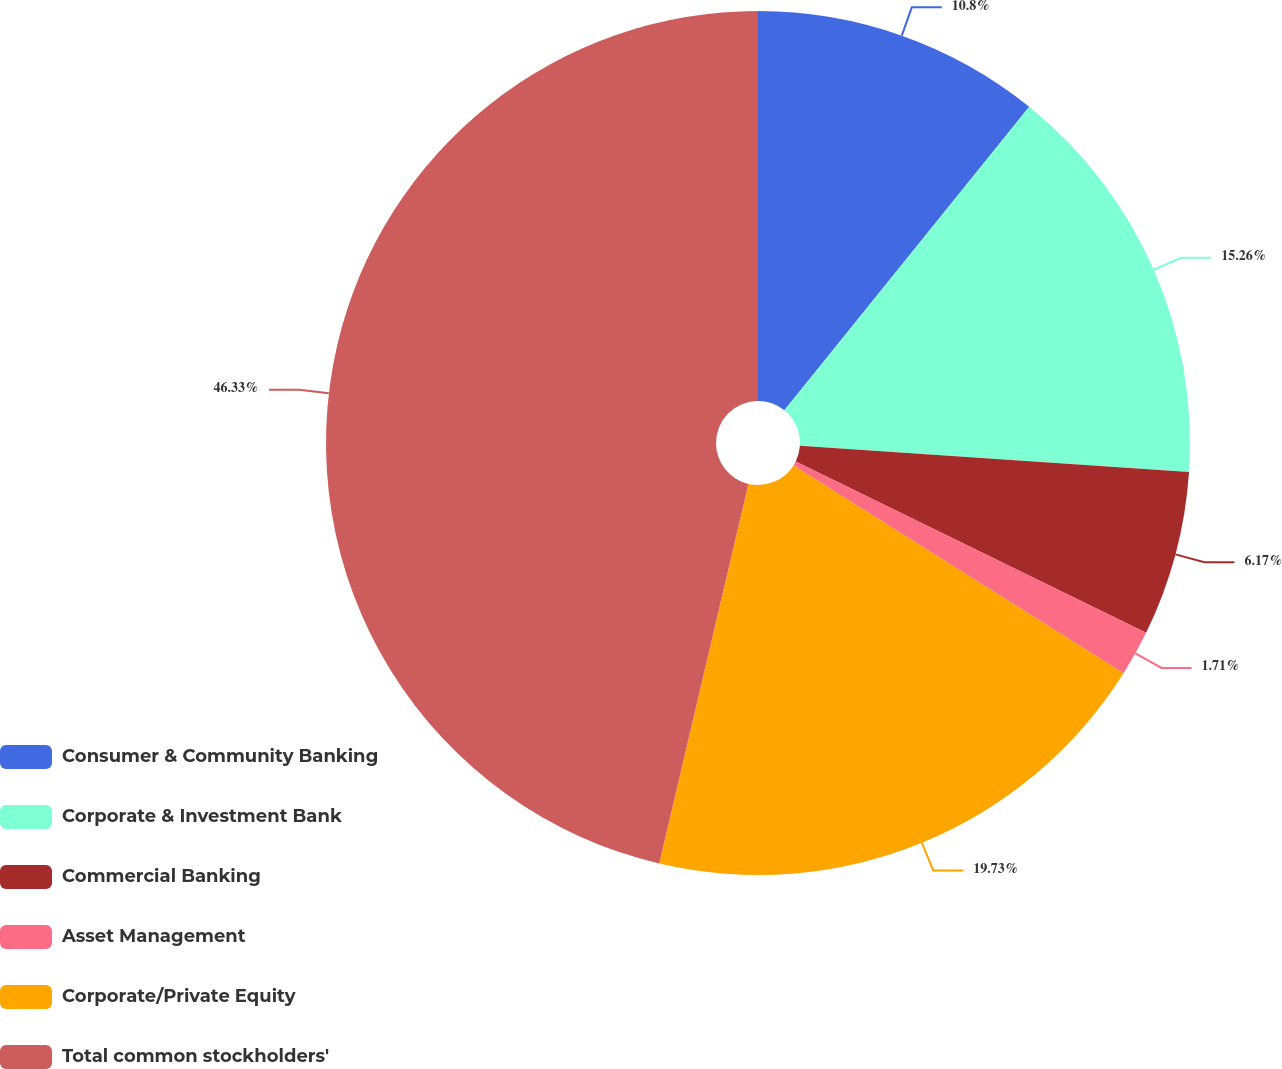<chart> <loc_0><loc_0><loc_500><loc_500><pie_chart><fcel>Consumer & Community Banking<fcel>Corporate & Investment Bank<fcel>Commercial Banking<fcel>Asset Management<fcel>Corporate/Private Equity<fcel>Total common stockholders'<nl><fcel>10.8%<fcel>15.26%<fcel>6.17%<fcel>1.71%<fcel>19.72%<fcel>46.32%<nl></chart> 